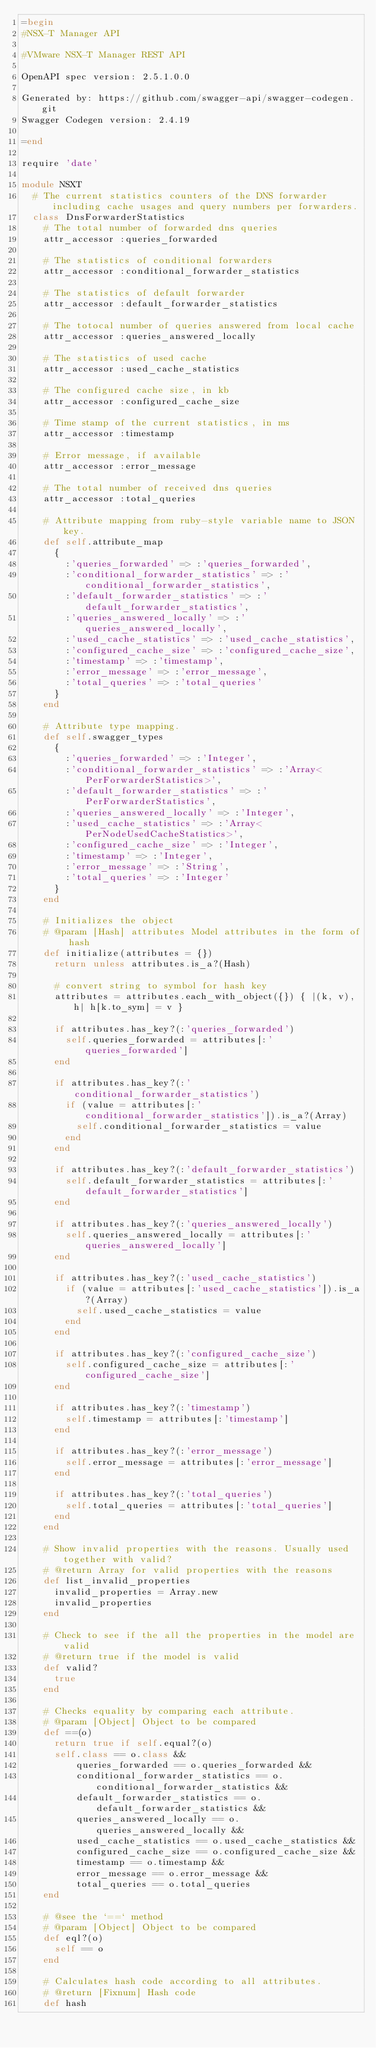Convert code to text. <code><loc_0><loc_0><loc_500><loc_500><_Ruby_>=begin
#NSX-T Manager API

#VMware NSX-T Manager REST API

OpenAPI spec version: 2.5.1.0.0

Generated by: https://github.com/swagger-api/swagger-codegen.git
Swagger Codegen version: 2.4.19

=end

require 'date'

module NSXT
  # The current statistics counters of the DNS forwarder including cache usages and query numbers per forwarders. 
  class DnsForwarderStatistics
    # The total number of forwarded dns queries
    attr_accessor :queries_forwarded

    # The statistics of conditional forwarders
    attr_accessor :conditional_forwarder_statistics

    # The statistics of default forwarder
    attr_accessor :default_forwarder_statistics

    # The totocal number of queries answered from local cache
    attr_accessor :queries_answered_locally

    # The statistics of used cache
    attr_accessor :used_cache_statistics

    # The configured cache size, in kb
    attr_accessor :configured_cache_size

    # Time stamp of the current statistics, in ms
    attr_accessor :timestamp

    # Error message, if available
    attr_accessor :error_message

    # The total number of received dns queries
    attr_accessor :total_queries

    # Attribute mapping from ruby-style variable name to JSON key.
    def self.attribute_map
      {
        :'queries_forwarded' => :'queries_forwarded',
        :'conditional_forwarder_statistics' => :'conditional_forwarder_statistics',
        :'default_forwarder_statistics' => :'default_forwarder_statistics',
        :'queries_answered_locally' => :'queries_answered_locally',
        :'used_cache_statistics' => :'used_cache_statistics',
        :'configured_cache_size' => :'configured_cache_size',
        :'timestamp' => :'timestamp',
        :'error_message' => :'error_message',
        :'total_queries' => :'total_queries'
      }
    end

    # Attribute type mapping.
    def self.swagger_types
      {
        :'queries_forwarded' => :'Integer',
        :'conditional_forwarder_statistics' => :'Array<PerForwarderStatistics>',
        :'default_forwarder_statistics' => :'PerForwarderStatistics',
        :'queries_answered_locally' => :'Integer',
        :'used_cache_statistics' => :'Array<PerNodeUsedCacheStatistics>',
        :'configured_cache_size' => :'Integer',
        :'timestamp' => :'Integer',
        :'error_message' => :'String',
        :'total_queries' => :'Integer'
      }
    end

    # Initializes the object
    # @param [Hash] attributes Model attributes in the form of hash
    def initialize(attributes = {})
      return unless attributes.is_a?(Hash)

      # convert string to symbol for hash key
      attributes = attributes.each_with_object({}) { |(k, v), h| h[k.to_sym] = v }

      if attributes.has_key?(:'queries_forwarded')
        self.queries_forwarded = attributes[:'queries_forwarded']
      end

      if attributes.has_key?(:'conditional_forwarder_statistics')
        if (value = attributes[:'conditional_forwarder_statistics']).is_a?(Array)
          self.conditional_forwarder_statistics = value
        end
      end

      if attributes.has_key?(:'default_forwarder_statistics')
        self.default_forwarder_statistics = attributes[:'default_forwarder_statistics']
      end

      if attributes.has_key?(:'queries_answered_locally')
        self.queries_answered_locally = attributes[:'queries_answered_locally']
      end

      if attributes.has_key?(:'used_cache_statistics')
        if (value = attributes[:'used_cache_statistics']).is_a?(Array)
          self.used_cache_statistics = value
        end
      end

      if attributes.has_key?(:'configured_cache_size')
        self.configured_cache_size = attributes[:'configured_cache_size']
      end

      if attributes.has_key?(:'timestamp')
        self.timestamp = attributes[:'timestamp']
      end

      if attributes.has_key?(:'error_message')
        self.error_message = attributes[:'error_message']
      end

      if attributes.has_key?(:'total_queries')
        self.total_queries = attributes[:'total_queries']
      end
    end

    # Show invalid properties with the reasons. Usually used together with valid?
    # @return Array for valid properties with the reasons
    def list_invalid_properties
      invalid_properties = Array.new
      invalid_properties
    end

    # Check to see if the all the properties in the model are valid
    # @return true if the model is valid
    def valid?
      true
    end

    # Checks equality by comparing each attribute.
    # @param [Object] Object to be compared
    def ==(o)
      return true if self.equal?(o)
      self.class == o.class &&
          queries_forwarded == o.queries_forwarded &&
          conditional_forwarder_statistics == o.conditional_forwarder_statistics &&
          default_forwarder_statistics == o.default_forwarder_statistics &&
          queries_answered_locally == o.queries_answered_locally &&
          used_cache_statistics == o.used_cache_statistics &&
          configured_cache_size == o.configured_cache_size &&
          timestamp == o.timestamp &&
          error_message == o.error_message &&
          total_queries == o.total_queries
    end

    # @see the `==` method
    # @param [Object] Object to be compared
    def eql?(o)
      self == o
    end

    # Calculates hash code according to all attributes.
    # @return [Fixnum] Hash code
    def hash</code> 